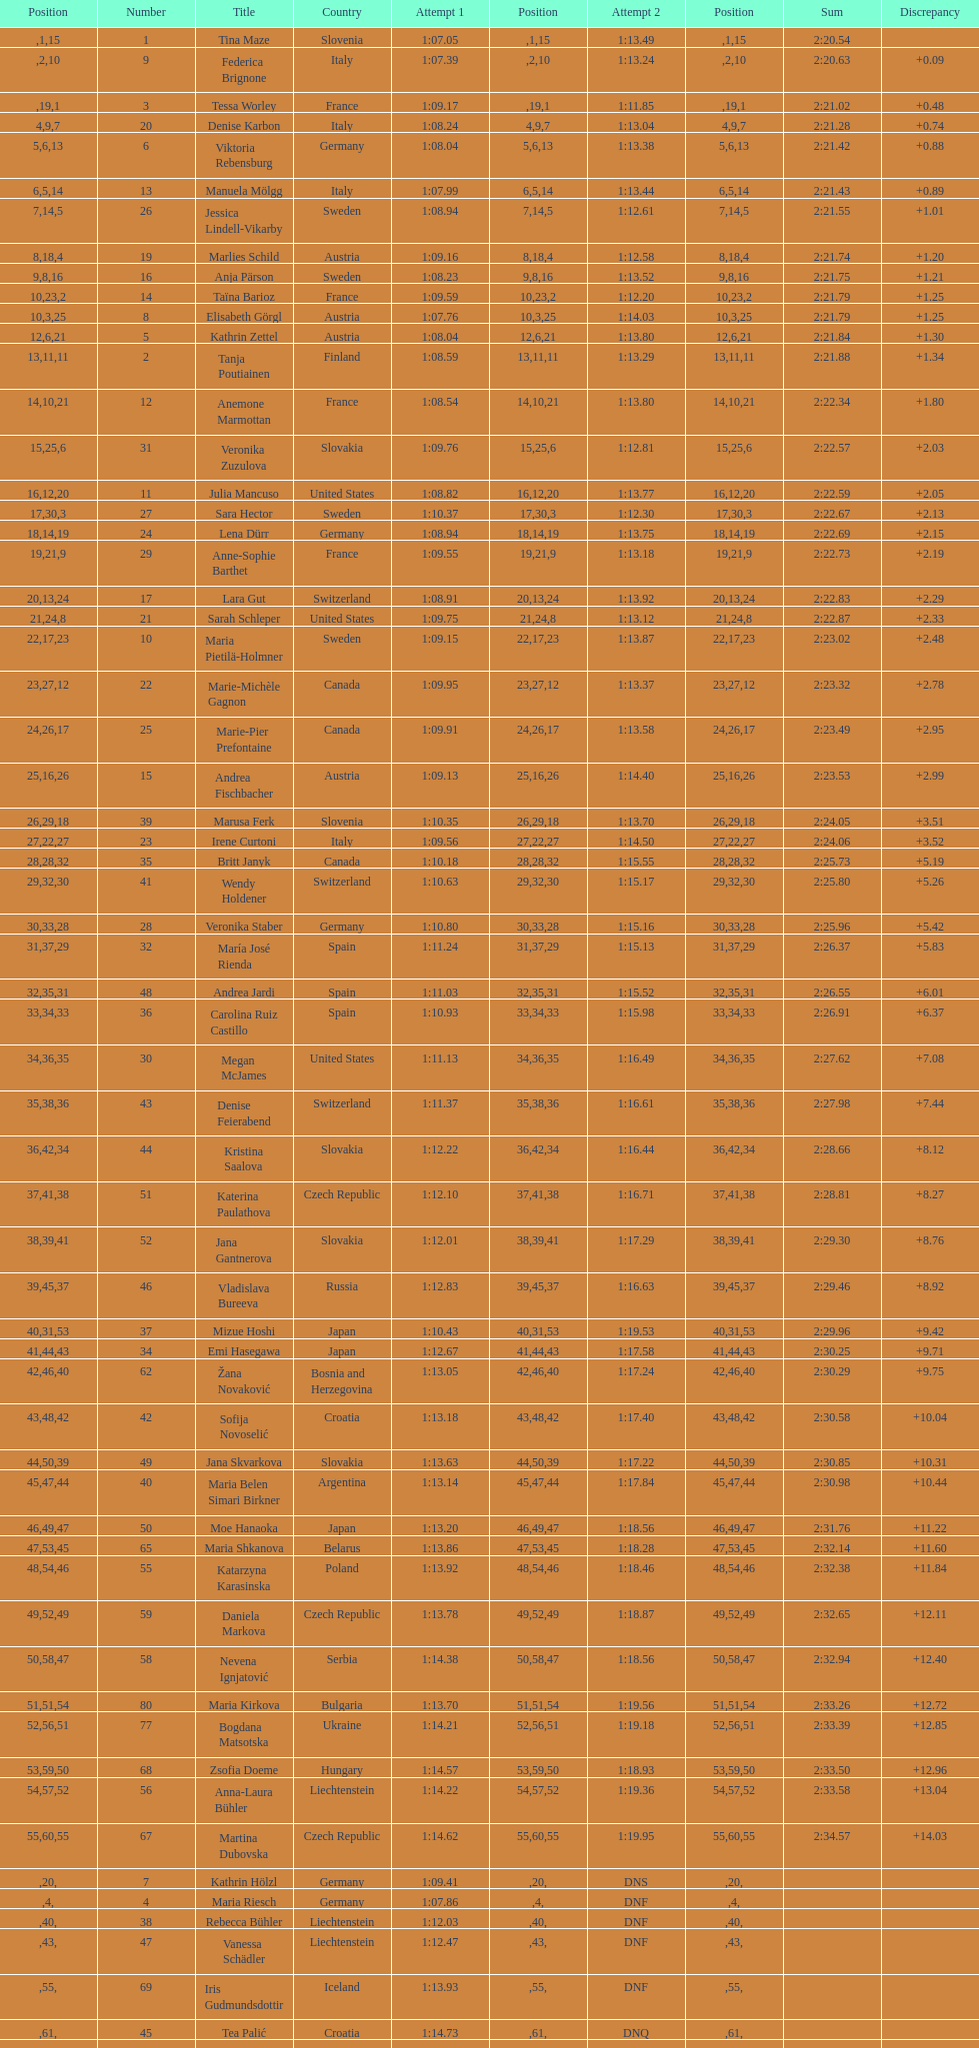What was the number of swedes in the top fifteen? 2. 